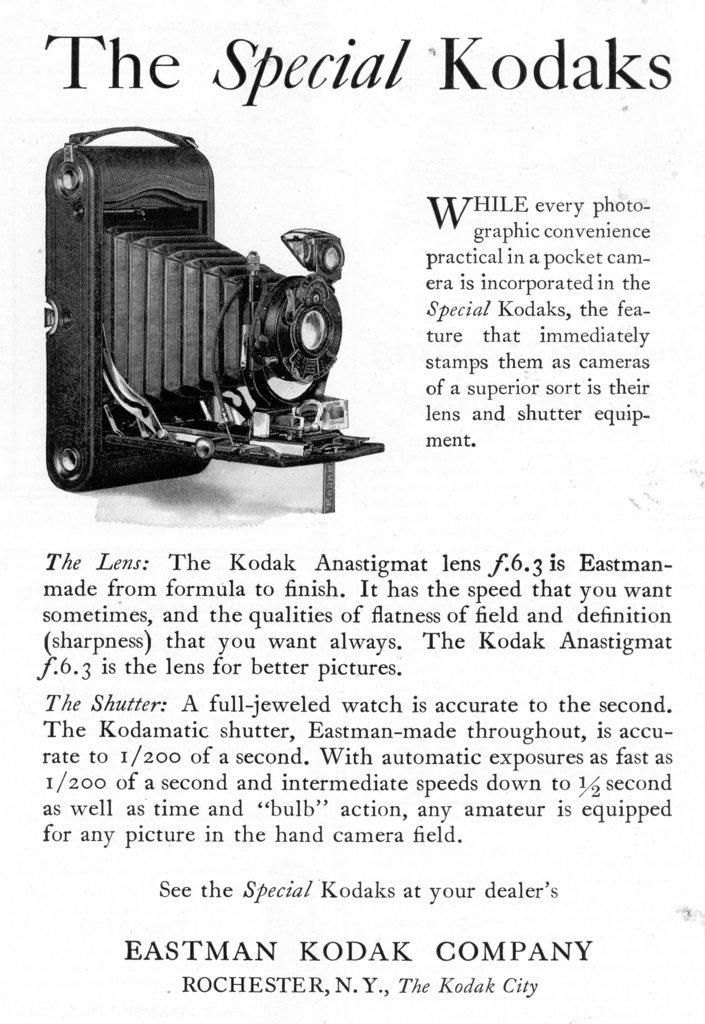What type of visual is the image? The image appears to be a poster. What is depicted in the main image on the poster? There is a picture of a camera on the poster. Are there any words or phrases on the poster? Yes, there is text on the poster. What color is the background of the poster? The background of the poster is white. Can you see the grip of the yak in the image? There is no yak or any reference to a grip in the image; it features a picture of a camera on a poster with text and a white background. 